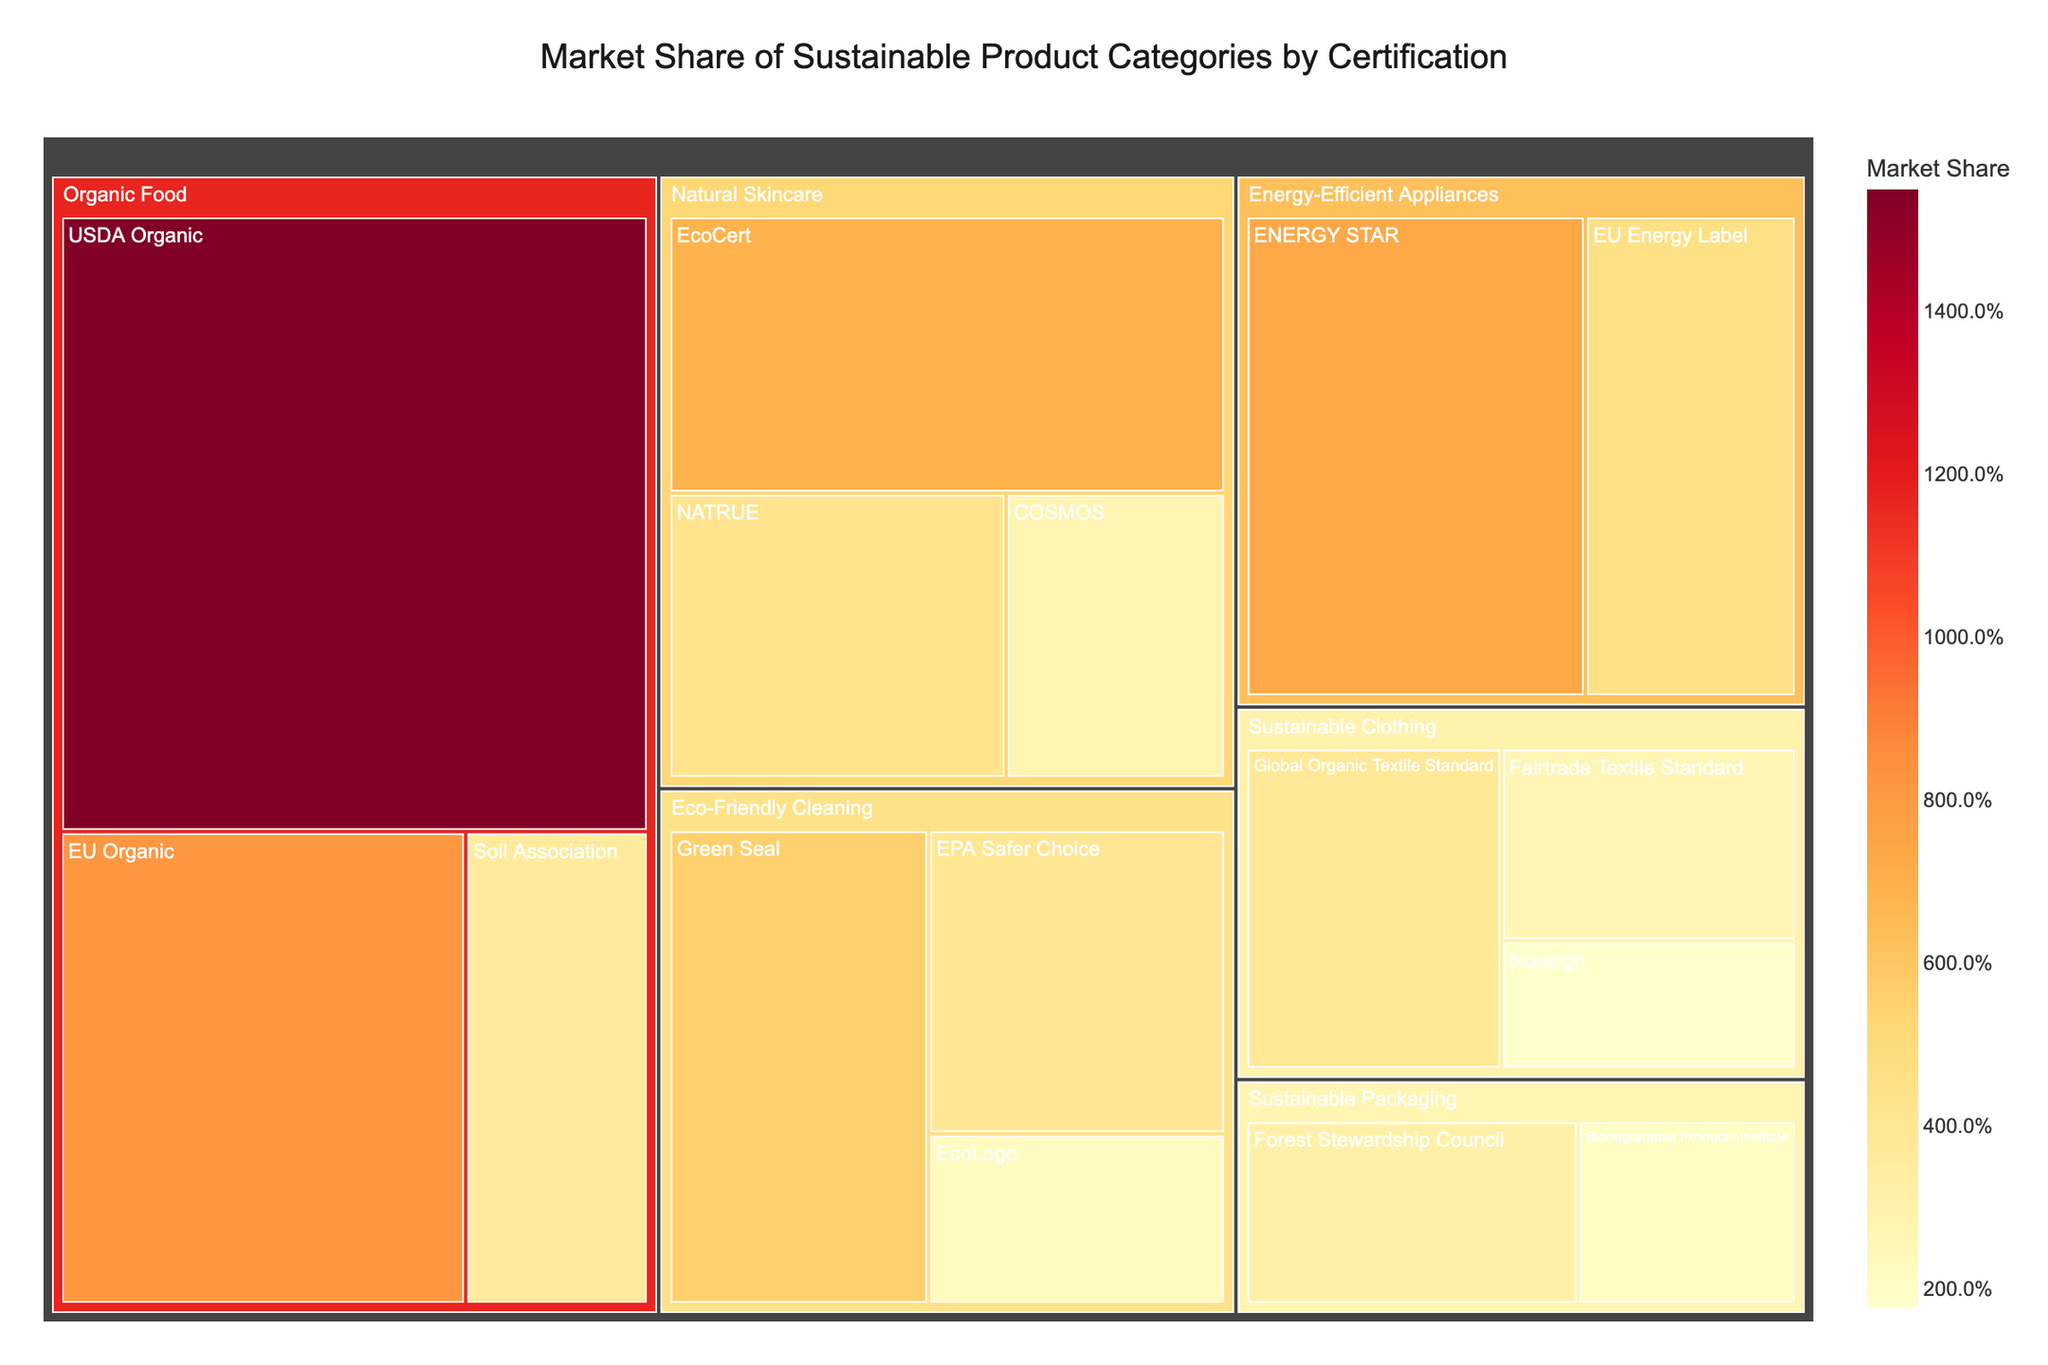What is the title of the Treemap? The title is the large text positioned at the top of the Treemap, providing an overview of what the chart represents.
Answer: Market Share of Sustainable Product Categories by Certification What is the market share of USDA Organic certification within the Organic Food category? Locate the Organic Food category in the Treemap and find the segment labeled USDA Organic. The market share value is displayed within this segment.
Answer: 15.5% Which category has the highest total market share, and what is its value? Sum the market share values for each category to determine the total market share. The category with the highest total will be the one with the largest overall market share.
Answer: Organic Food, 27.4% How does the market share of ENERGY STAR compare to EU Energy Label in the Energy-Efficient Appliances category? Find both ENERGY STAR and EU Energy Label within the Energy-Efficient Appliances category and compare their market share values.
Answer: ENERGY STAR has a higher market share (7.4%) compared to EU Energy Label (4.6%) What is the combined market share of Sustainable Clothing certifications? Add the market shares of the certifications under the Sustainable Clothing category. This involves summing up the values for Global Organic Textile Standard, Fairtrade Textile Standard, and bluesign.
Answer: 3.9% + 2.7% + 1.8% = 8.4% Which certification has the lowest market share overall, and what is its value? Identify the smallest market share value across all categories and note the corresponding certification.
Answer: bluesign, 1.8% What is the total market share of all Eco-Friendly Cleaning products? Add together the market shares of all certifications within the Eco-Friendly Cleaning category. This provides the total market share for the category.
Answer: 5.6% + 4.1% + 2.3% = 12.0% Among the Natural Skincare certifications, which one has the smallest market share and what is its percentage? Within the Natural Skincare category, identify the certification segment with the smallest market share value.
Answer: COSMOS, 2.8% How does the market share of Forest Stewardship Council compare to Biodegradable Products Institute in the Sustainable Packaging category? Find the Forest Stewardship Council and Biodegradable Products Institute segments within the Sustainable Packaging category and compare their displayed market shares.
Answer: Forest Stewardship Council has a higher market share (3.2%) compared to Biodegradable Products Institute (2.1%) Which category has the most diverse range of certifications based on the treemap structure? Evaluate the number of different certifications listed under each category segment in the Treemap.
Answer: Organic Food (3 certifications) 